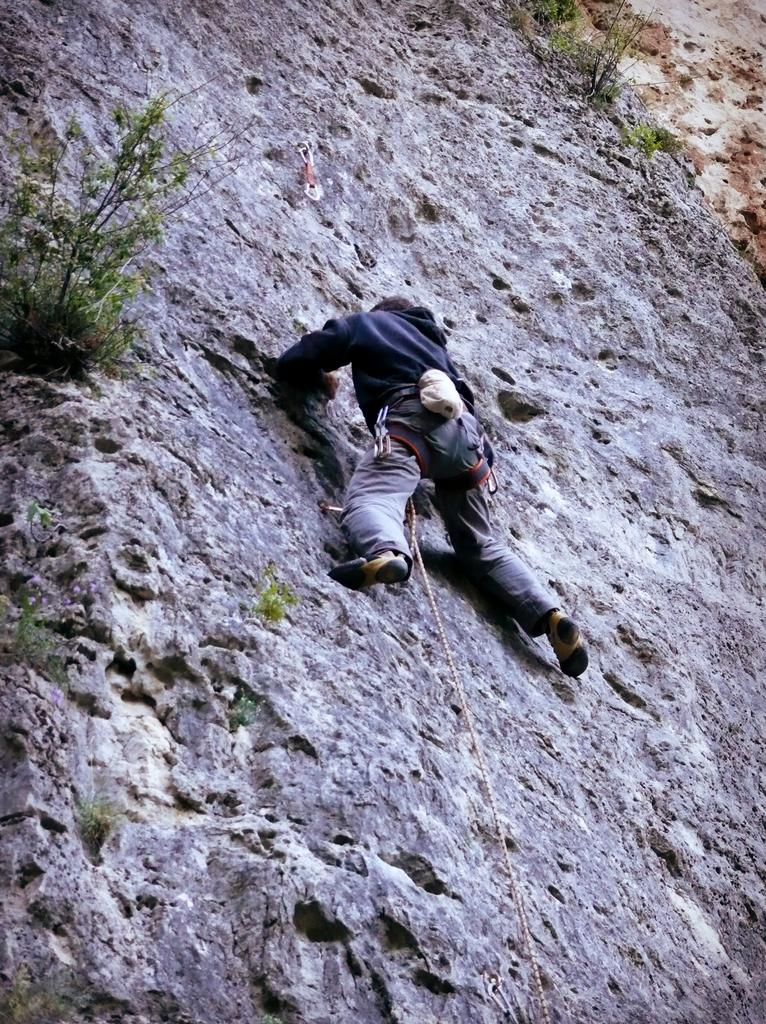What is the main activity being performed by the person in the image? The person is climbing a mountain in the image. What can be seen in the background or surrounding the person? There are plants visible in the image. What type of skate is the person using to climb the mountain in the image? There is no skate present in the image; the person is climbing the mountain on foot. How many children are visible in the image? There are no children visible in the image; it only features a person climbing a mountain. 